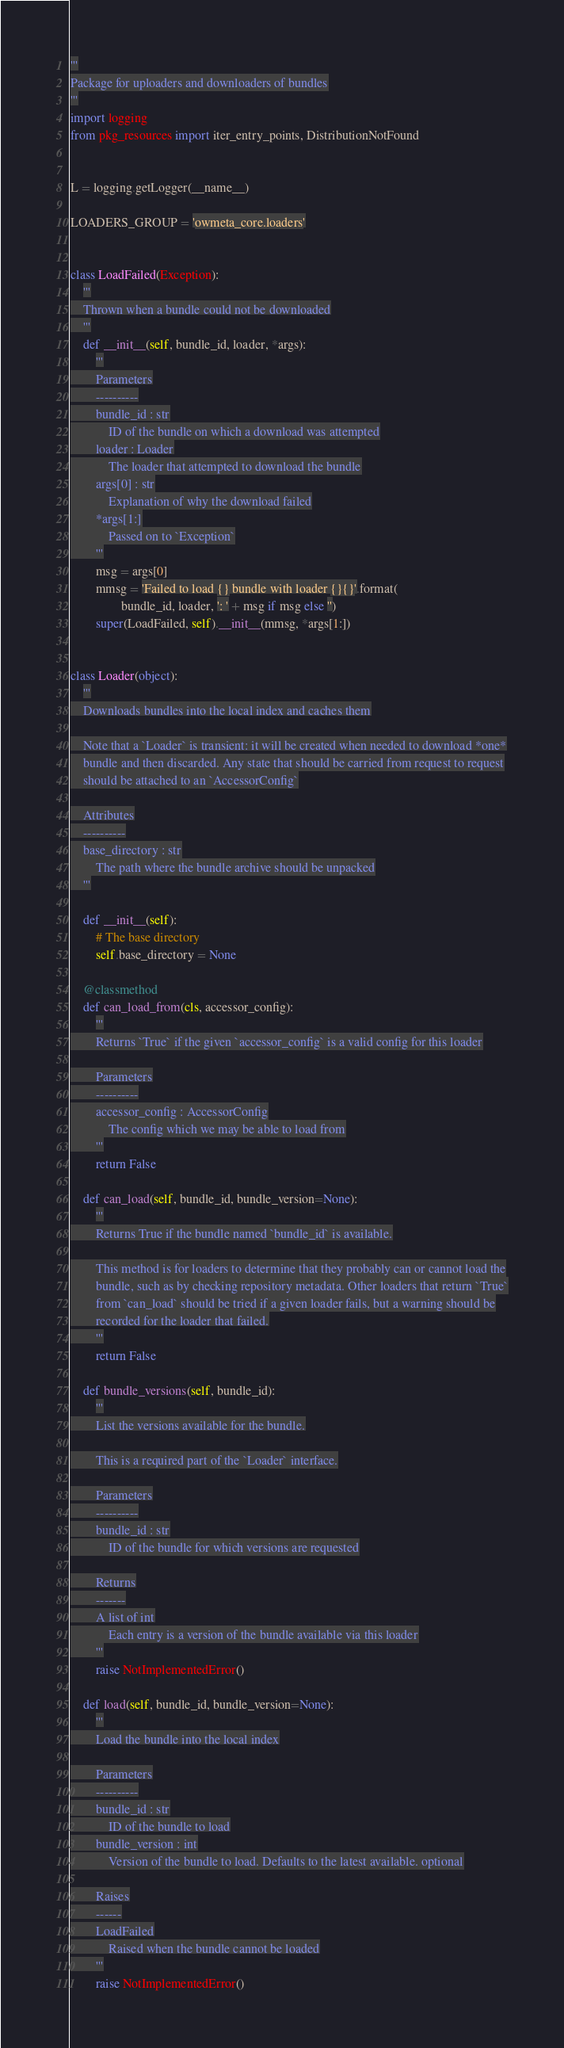<code> <loc_0><loc_0><loc_500><loc_500><_Python_>'''
Package for uploaders and downloaders of bundles
'''
import logging
from pkg_resources import iter_entry_points, DistributionNotFound


L = logging.getLogger(__name__)

LOADERS_GROUP = 'owmeta_core.loaders'


class LoadFailed(Exception):
    '''
    Thrown when a bundle could not be downloaded
    '''
    def __init__(self, bundle_id, loader, *args):
        '''
        Parameters
        ----------
        bundle_id : str
            ID of the bundle on which a download was attempted
        loader : Loader
            The loader that attempted to download the bundle
        args[0] : str
            Explanation of why the download failed
        *args[1:]
            Passed on to `Exception`
        '''
        msg = args[0]
        mmsg = 'Failed to load {} bundle with loader {}{}'.format(
                bundle_id, loader, ': ' + msg if msg else '')
        super(LoadFailed, self).__init__(mmsg, *args[1:])


class Loader(object):
    '''
    Downloads bundles into the local index and caches them

    Note that a `Loader` is transient: it will be created when needed to download *one*
    bundle and then discarded. Any state that should be carried from request to request
    should be attached to an `AccessorConfig`

    Attributes
    ----------
    base_directory : str
        The path where the bundle archive should be unpacked
    '''

    def __init__(self):
        # The base directory
        self.base_directory = None

    @classmethod
    def can_load_from(cls, accessor_config):
        '''
        Returns `True` if the given `accessor_config` is a valid config for this loader

        Parameters
        ----------
        accessor_config : AccessorConfig
            The config which we may be able to load from
        '''
        return False

    def can_load(self, bundle_id, bundle_version=None):
        '''
        Returns True if the bundle named `bundle_id` is available.

        This method is for loaders to determine that they probably can or cannot load the
        bundle, such as by checking repository metadata. Other loaders that return `True`
        from `can_load` should be tried if a given loader fails, but a warning should be
        recorded for the loader that failed.
        '''
        return False

    def bundle_versions(self, bundle_id):
        '''
        List the versions available for the bundle.

        This is a required part of the `Loader` interface.

        Parameters
        ----------
        bundle_id : str
            ID of the bundle for which versions are requested

        Returns
        -------
        A list of int
            Each entry is a version of the bundle available via this loader
        '''
        raise NotImplementedError()

    def load(self, bundle_id, bundle_version=None):
        '''
        Load the bundle into the local index

        Parameters
        ----------
        bundle_id : str
            ID of the bundle to load
        bundle_version : int
            Version of the bundle to load. Defaults to the latest available. optional

        Raises
        ------
        LoadFailed
            Raised when the bundle cannot be loaded
        '''
        raise NotImplementedError()
</code> 